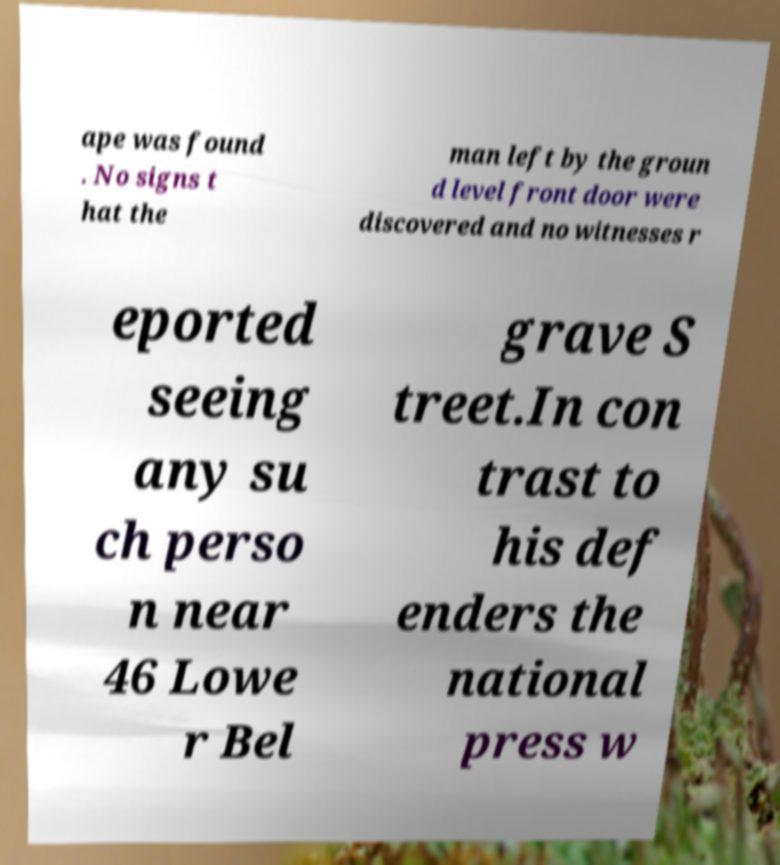I need the written content from this picture converted into text. Can you do that? ape was found . No signs t hat the man left by the groun d level front door were discovered and no witnesses r eported seeing any su ch perso n near 46 Lowe r Bel grave S treet.In con trast to his def enders the national press w 